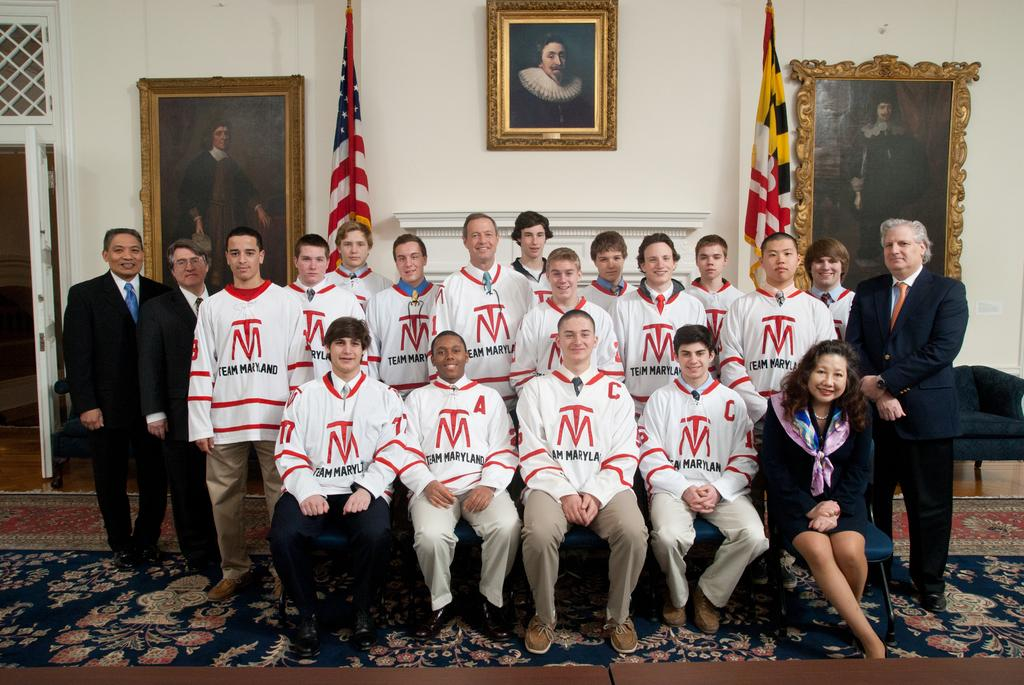<image>
Describe the image concisely. Three rows of young men, all wearing matching shirts that say Team Maryland, are in a large room, posing for a team photo. 